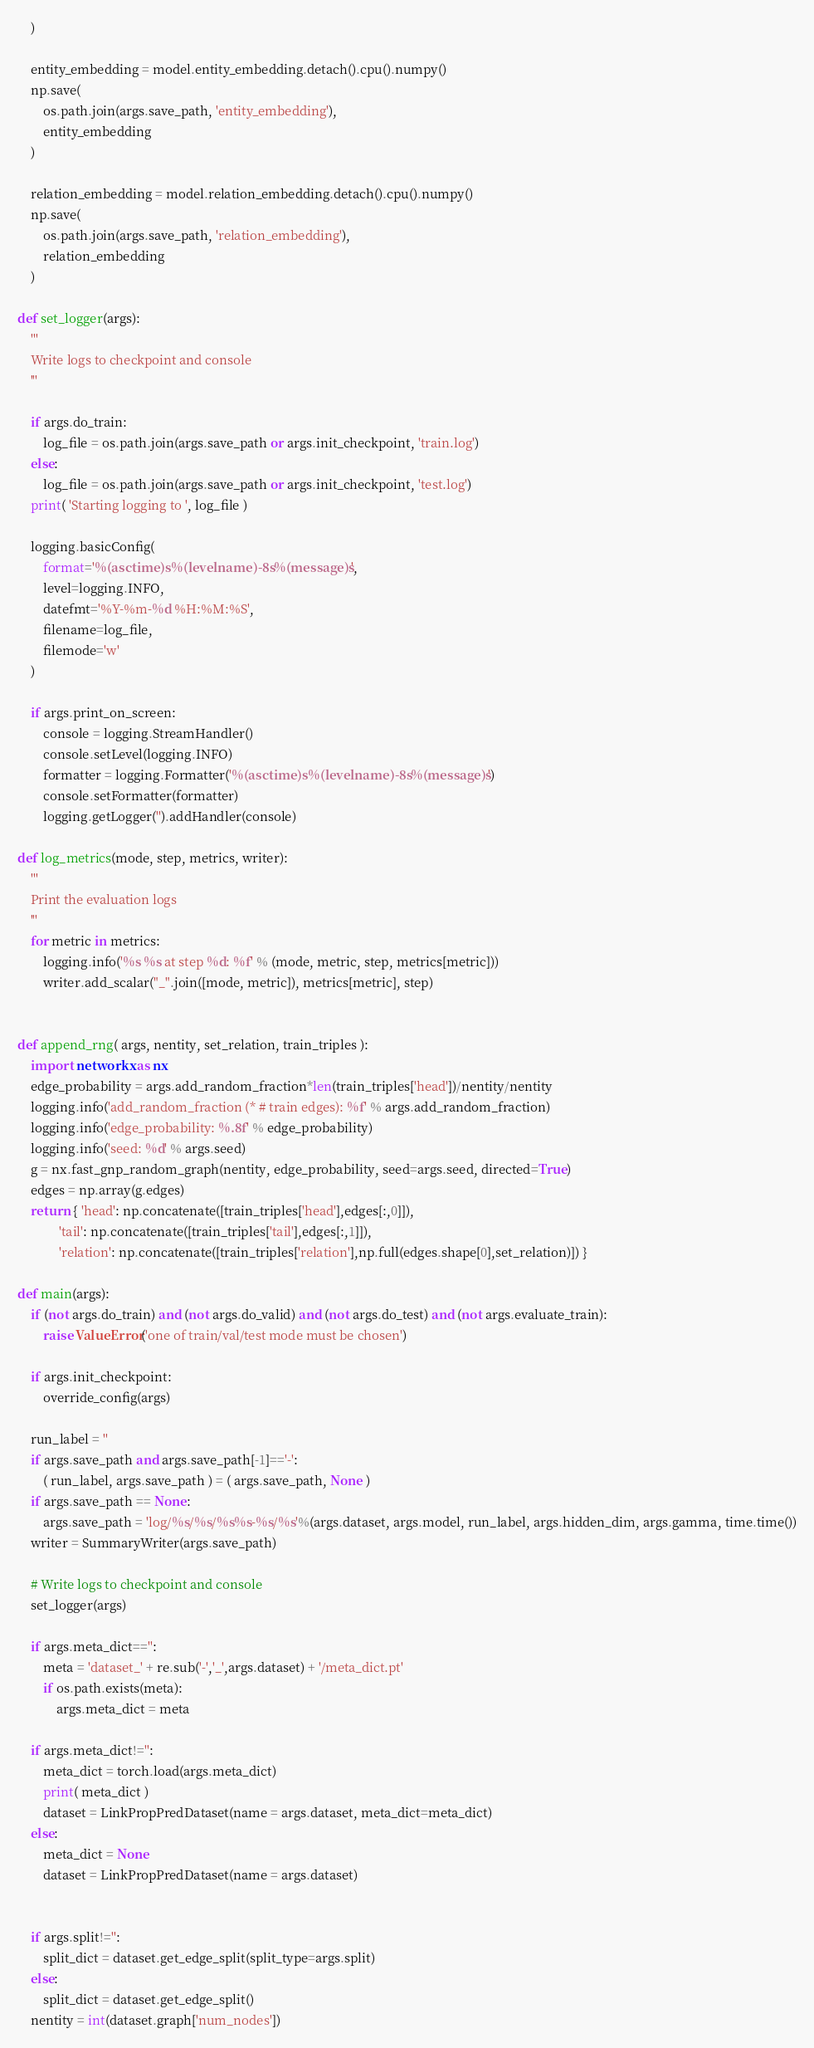Convert code to text. <code><loc_0><loc_0><loc_500><loc_500><_Python_>    )
    
    entity_embedding = model.entity_embedding.detach().cpu().numpy()
    np.save(
        os.path.join(args.save_path, 'entity_embedding'), 
        entity_embedding
    )
    
    relation_embedding = model.relation_embedding.detach().cpu().numpy()
    np.save(
        os.path.join(args.save_path, 'relation_embedding'), 
        relation_embedding
    )

def set_logger(args):
    '''
    Write logs to checkpoint and console
    '''

    if args.do_train:
        log_file = os.path.join(args.save_path or args.init_checkpoint, 'train.log')
    else:
        log_file = os.path.join(args.save_path or args.init_checkpoint, 'test.log')
    print( 'Starting logging to ', log_file )

    logging.basicConfig(
        format='%(asctime)s %(levelname)-8s %(message)s',
        level=logging.INFO,
        datefmt='%Y-%m-%d %H:%M:%S',
        filename=log_file,
        filemode='w'
    )

    if args.print_on_screen:
        console = logging.StreamHandler()
        console.setLevel(logging.INFO)
        formatter = logging.Formatter('%(asctime)s %(levelname)-8s %(message)s')
        console.setFormatter(formatter)
        logging.getLogger('').addHandler(console)

def log_metrics(mode, step, metrics, writer):
    '''
    Print the evaluation logs
    '''
    for metric in metrics:
        logging.info('%s %s at step %d: %f' % (mode, metric, step, metrics[metric]))
        writer.add_scalar("_".join([mode, metric]), metrics[metric], step)
        

def append_rng( args, nentity, set_relation, train_triples ):
    import networkx as nx
    edge_probability = args.add_random_fraction*len(train_triples['head'])/nentity/nentity
    logging.info('add_random_fraction (* # train edges): %f' % args.add_random_fraction)
    logging.info('edge_probability: %.8f' % edge_probability)
    logging.info('seed: %d' % args.seed)
    g = nx.fast_gnp_random_graph(nentity, edge_probability, seed=args.seed, directed=True)
    edges = np.array(g.edges)
    return { 'head': np.concatenate([train_triples['head'],edges[:,0]]),
             'tail': np.concatenate([train_triples['tail'],edges[:,1]]),
             'relation': np.concatenate([train_triples['relation'],np.full(edges.shape[0],set_relation)]) }
        
def main(args):
    if (not args.do_train) and (not args.do_valid) and (not args.do_test) and (not args.evaluate_train):
        raise ValueError('one of train/val/test mode must be chosen')
    
    if args.init_checkpoint:
        override_config(args)

    run_label = ''
    if args.save_path and args.save_path[-1]=='-':        
        ( run_label, args.save_path ) = ( args.save_path, None )
    if args.save_path == None:
        args.save_path = 'log/%s/%s/%s%s-%s/%s'%(args.dataset, args.model, run_label, args.hidden_dim, args.gamma, time.time())
    writer = SummaryWriter(args.save_path)
    
    # Write logs to checkpoint and console
    set_logger(args)

    if args.meta_dict=='':
        meta = 'dataset_' + re.sub('-','_',args.dataset) + '/meta_dict.pt'
        if os.path.exists(meta):
            args.meta_dict = meta
        
    if args.meta_dict!='':
        meta_dict = torch.load(args.meta_dict)
        print( meta_dict )
        dataset = LinkPropPredDataset(name = args.dataset, meta_dict=meta_dict)
    else:
        meta_dict = None
        dataset = LinkPropPredDataset(name = args.dataset)


    if args.split!='':
        split_dict = dataset.get_edge_split(split_type=args.split)
    else:
        split_dict = dataset.get_edge_split()
    nentity = int(dataset.graph['num_nodes'])</code> 